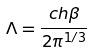<formula> <loc_0><loc_0><loc_500><loc_500>\Lambda = \frac { c h \beta } { 2 \pi ^ { 1 / 3 } }</formula> 